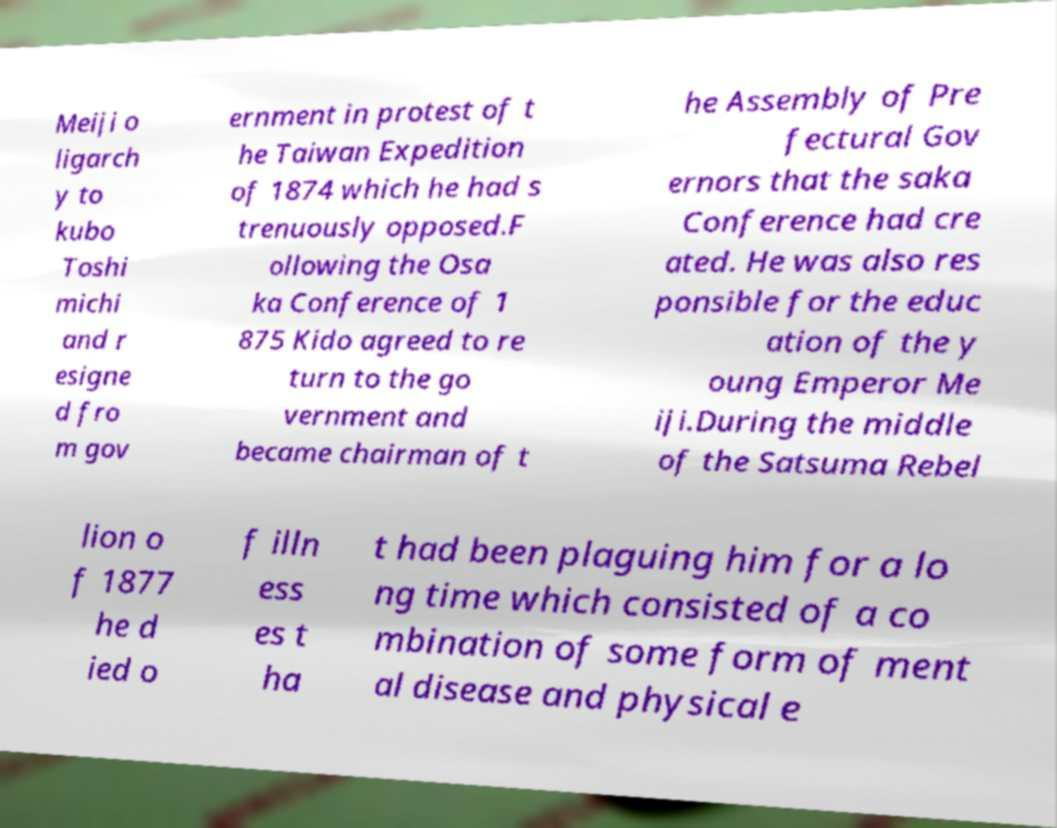Please identify and transcribe the text found in this image. Meiji o ligarch y to kubo Toshi michi and r esigne d fro m gov ernment in protest of t he Taiwan Expedition of 1874 which he had s trenuously opposed.F ollowing the Osa ka Conference of 1 875 Kido agreed to re turn to the go vernment and became chairman of t he Assembly of Pre fectural Gov ernors that the saka Conference had cre ated. He was also res ponsible for the educ ation of the y oung Emperor Me iji.During the middle of the Satsuma Rebel lion o f 1877 he d ied o f illn ess es t ha t had been plaguing him for a lo ng time which consisted of a co mbination of some form of ment al disease and physical e 